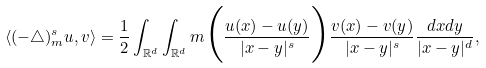<formula> <loc_0><loc_0><loc_500><loc_500>\langle ( - \triangle ) ^ { s } _ { m } u , v \rangle = \frac { 1 } { 2 } \int _ { \mathbb { R } ^ { d } } \int _ { \mathbb { R } ^ { d } } m \Big { ( } \frac { u ( x ) - u ( y ) } { | x - y | ^ { s } } \Big { ) } \frac { v ( x ) - v ( y ) } { | x - y | ^ { s } } \frac { d x d y } { | x - y | ^ { d } } ,</formula> 